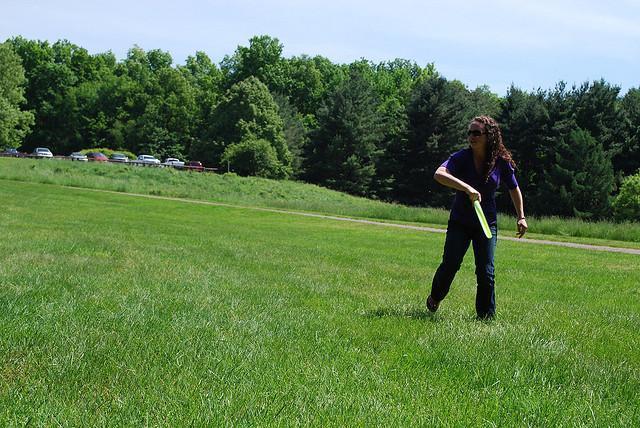How many people are wearing hats?
Give a very brief answer. 0. 